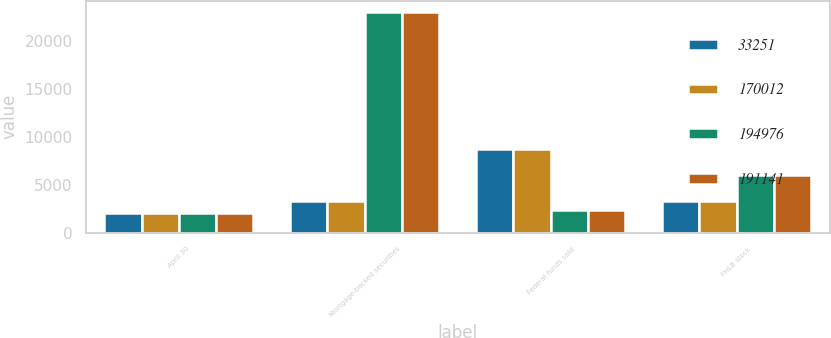Convert chart. <chart><loc_0><loc_0><loc_500><loc_500><stacked_bar_chart><ecel><fcel>April 30<fcel>Mortgage-backed securities<fcel>Federal funds sold<fcel>FHLB stock<nl><fcel>33251<fcel>2011<fcel>3315<fcel>8727<fcel>3315<nl><fcel>170012<fcel>2011<fcel>3315<fcel>8727<fcel>3315<nl><fcel>194976<fcel>2010<fcel>23026<fcel>2338<fcel>6033<nl><fcel>191141<fcel>2010<fcel>23016<fcel>2338<fcel>6033<nl></chart> 